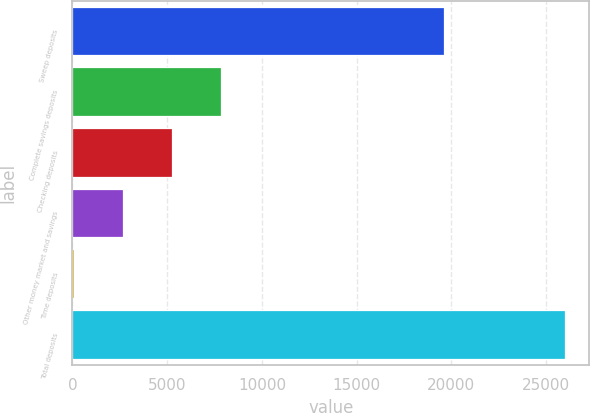<chart> <loc_0><loc_0><loc_500><loc_500><bar_chart><fcel>Sweep deposits<fcel>Complete savings deposits<fcel>Checking deposits<fcel>Other money market and savings<fcel>Time deposits<fcel>Total deposits<nl><fcel>19592.1<fcel>7835.93<fcel>5245.22<fcel>2654.51<fcel>63.8<fcel>25970.9<nl></chart> 